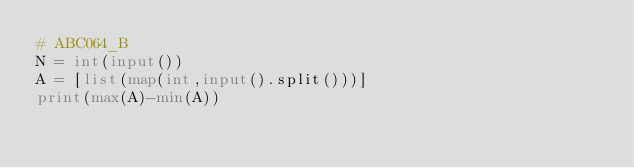Convert code to text. <code><loc_0><loc_0><loc_500><loc_500><_Python_># ABC064_B
N = int(input())
A = [list(map(int,input().split()))]
print(max(A)-min(A))</code> 